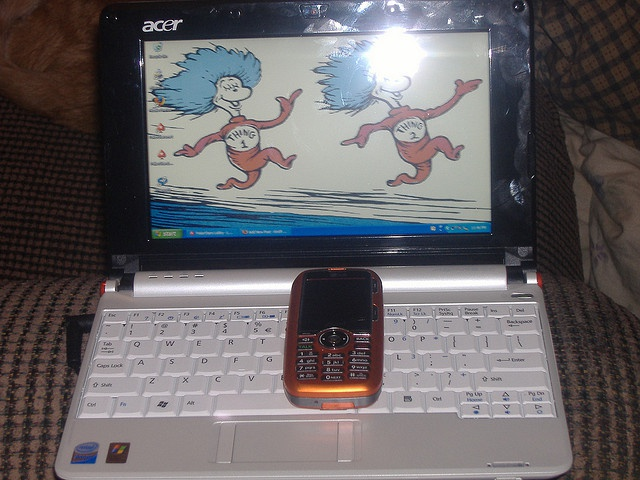Describe the objects in this image and their specific colors. I can see laptop in darkgray, black, lightgray, and gray tones and cell phone in black, maroon, gray, and brown tones in this image. 